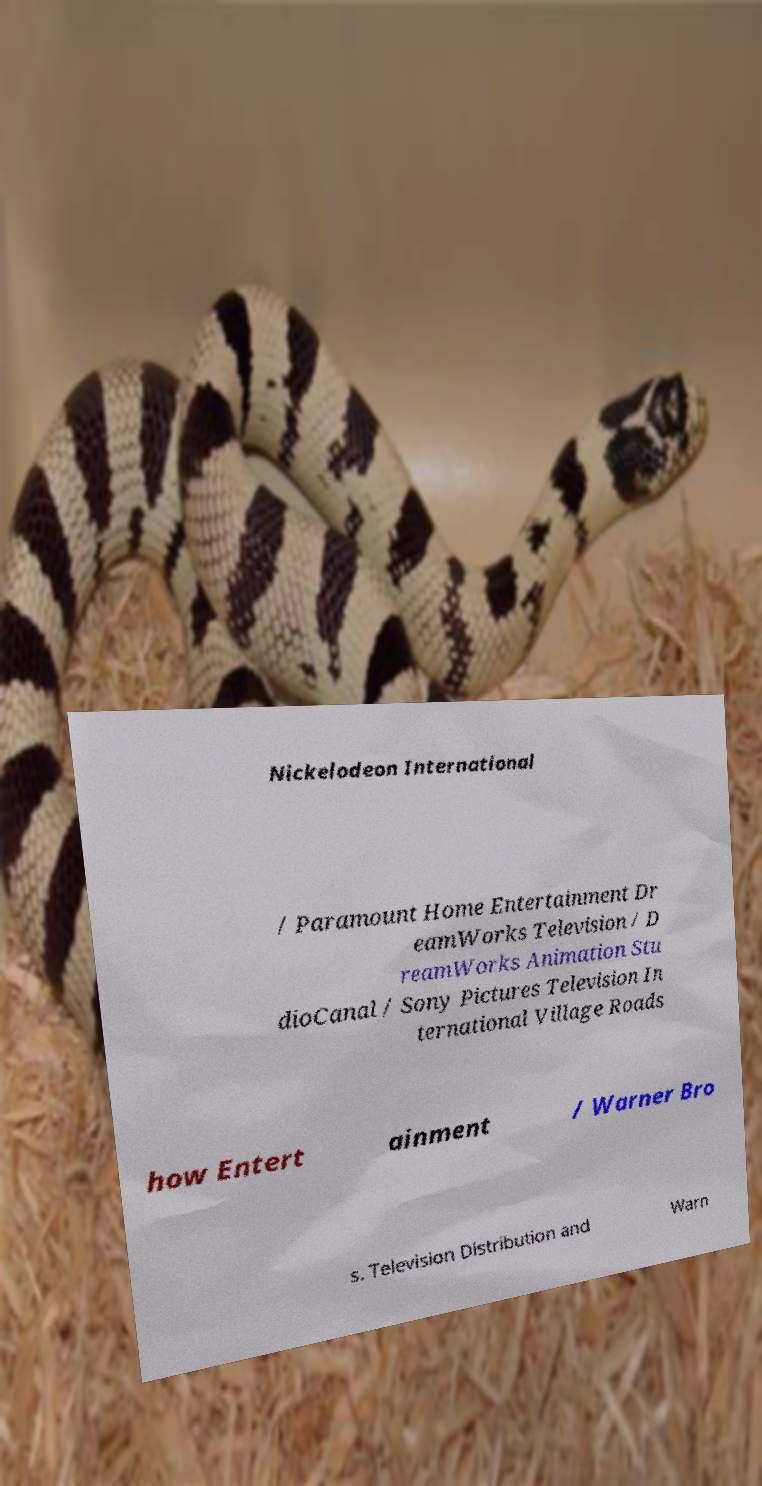For documentation purposes, I need the text within this image transcribed. Could you provide that? Nickelodeon International / Paramount Home Entertainment Dr eamWorks Television / D reamWorks Animation Stu dioCanal / Sony Pictures Television In ternational Village Roads how Entert ainment / Warner Bro s. Television Distribution and Warn 